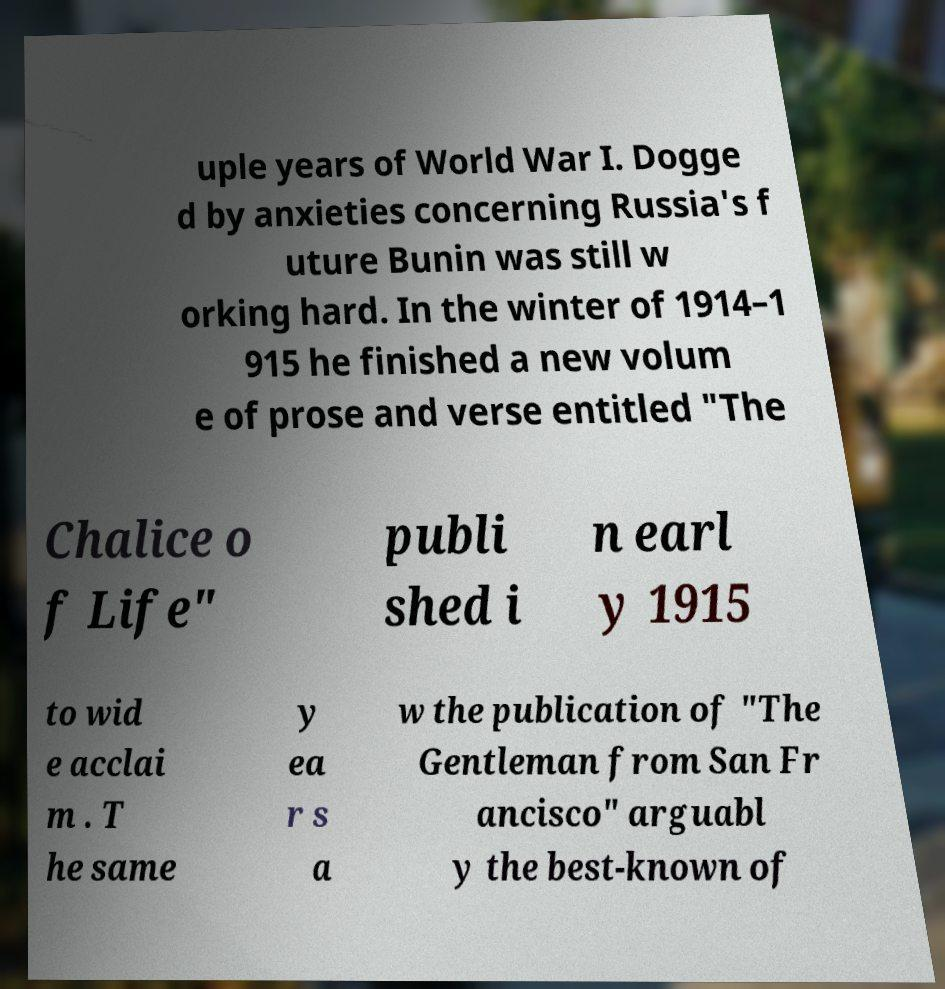I need the written content from this picture converted into text. Can you do that? uple years of World War I. Dogge d by anxieties concerning Russia's f uture Bunin was still w orking hard. In the winter of 1914–1 915 he finished a new volum e of prose and verse entitled "The Chalice o f Life" publi shed i n earl y 1915 to wid e acclai m . T he same y ea r s a w the publication of "The Gentleman from San Fr ancisco" arguabl y the best-known of 